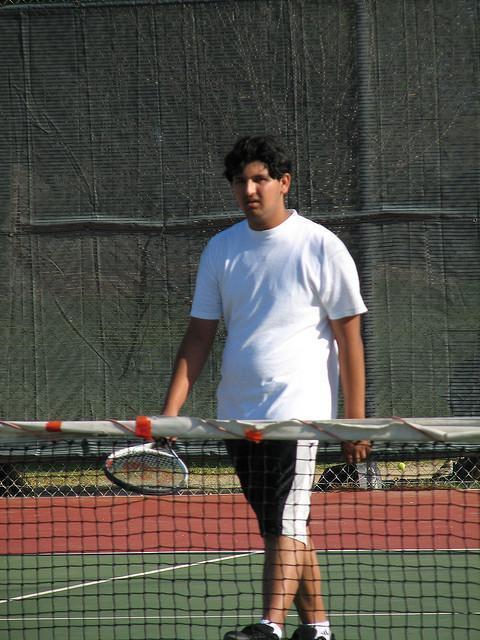How many tennis rackets are in the picture?
Give a very brief answer. 1. How many horses are in the picture?
Give a very brief answer. 0. 